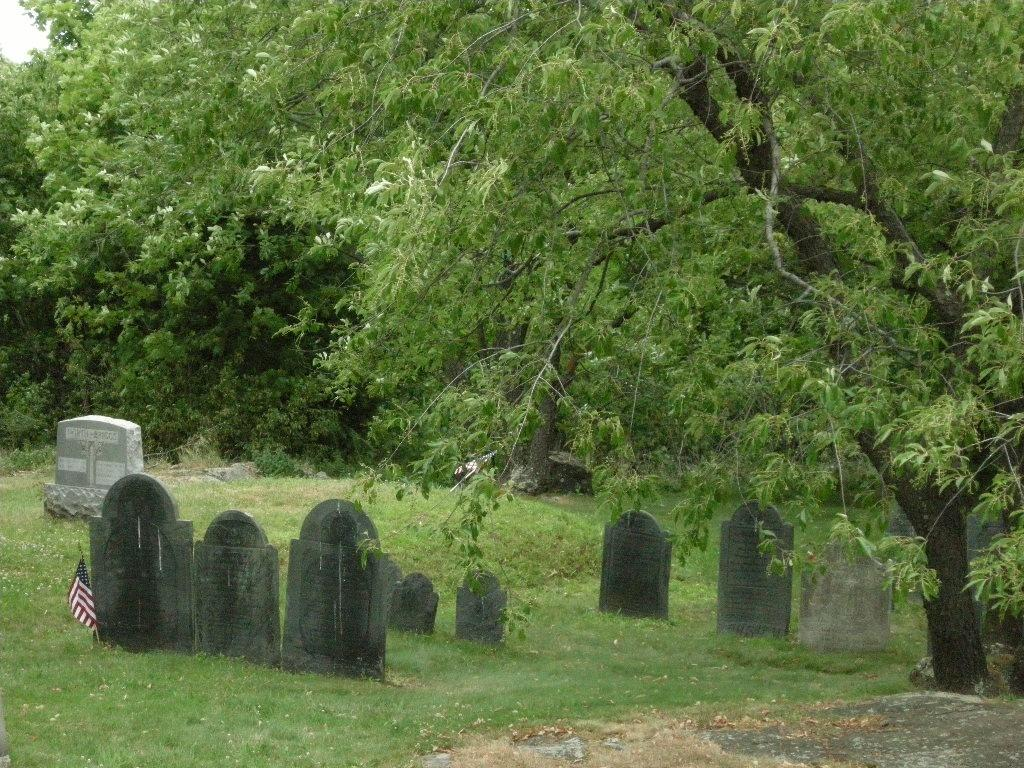What type of vegetation can be seen in the image? There are trees in the image. What type of structures are present in the image? There are gravestones in the image. What is the object with colors and patterns in the image? There is a flag in the image. What type of ground cover is visible in the image? Grass is present on the ground in the image. What type of notebook is visible on the gravestone in the image? There is no notebook present in the image; it features trees, gravestones, a flag, and grass. What is the value of the turkey in the image? There is no turkey present in the image, so it is not possible to determine its value. 